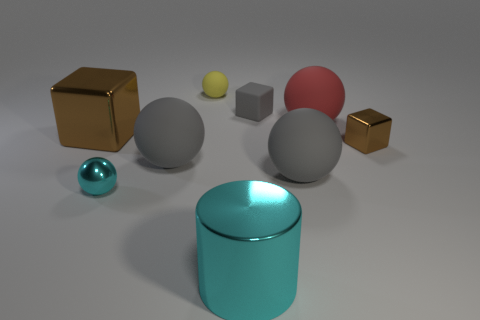Subtract all brown shiny blocks. How many blocks are left? 1 Subtract all red balls. How many brown blocks are left? 2 Add 1 big brown objects. How many objects exist? 10 Subtract all cylinders. How many objects are left? 8 Subtract all gray spheres. How many spheres are left? 3 Subtract 2 balls. How many balls are left? 3 Add 2 big matte objects. How many big matte objects are left? 5 Add 1 red matte balls. How many red matte balls exist? 2 Subtract 2 brown cubes. How many objects are left? 7 Subtract all gray spheres. Subtract all yellow cylinders. How many spheres are left? 3 